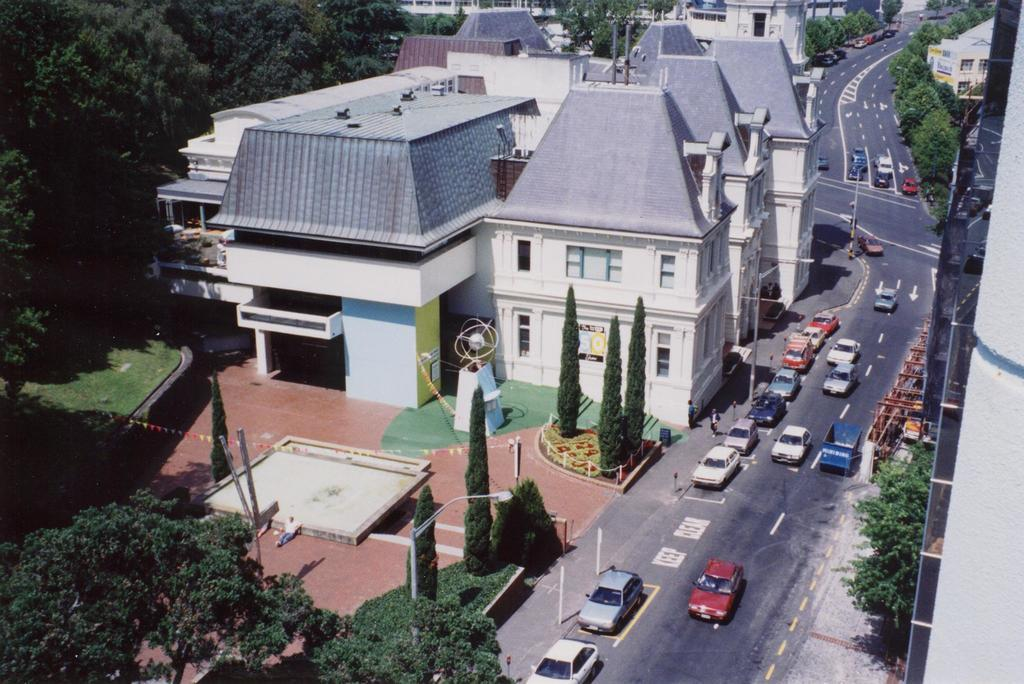What can be seen on the road in the image? There are vehicles on the road in the image. What type of structures are visible in the image? There are houses with roofs and windows in the image. What natural elements are present in the image? There are trees and plants in the image. What man-made object can be seen in the image? There is a street pole in the image. What type of peace symbol can be seen hanging from the street pole in the image? There is no peace symbol hanging from the street pole in the image. What type of surprise can be seen on the faces of the people in the image? There are no people present in the image, so it is not possible to determine their expressions or any surprises they might be experiencing. 